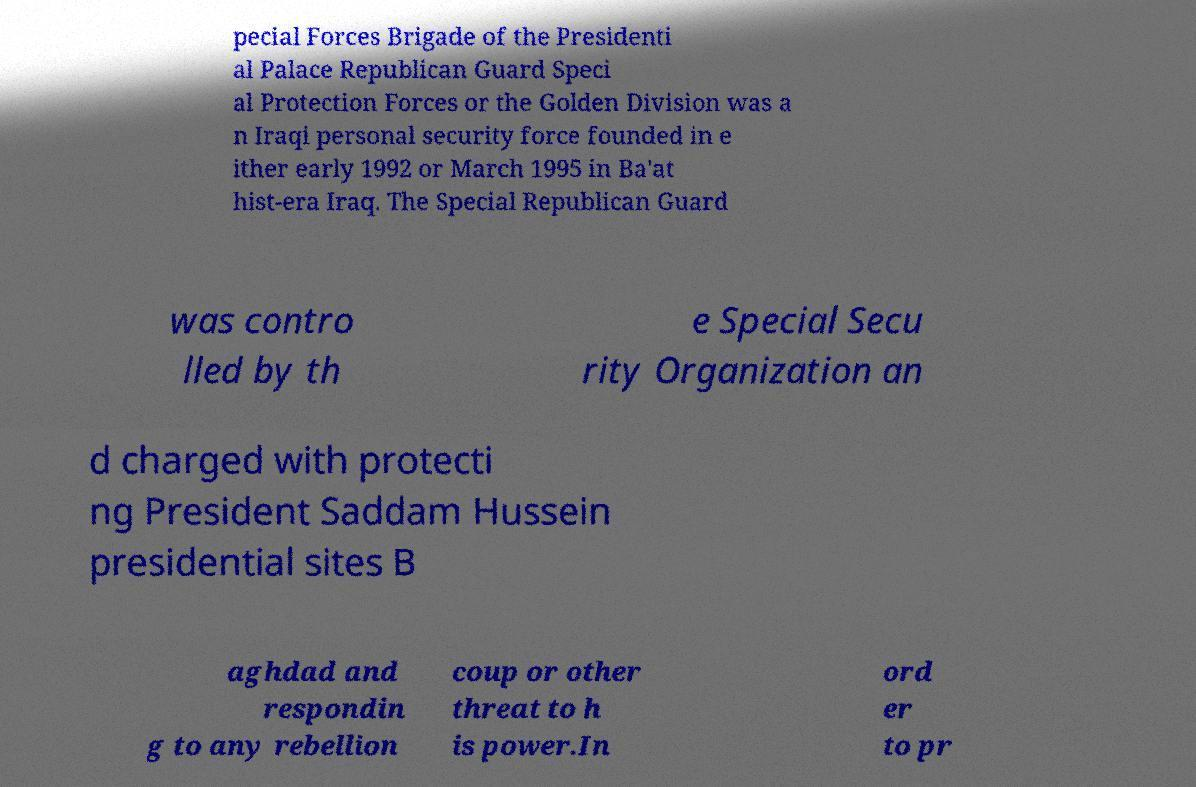Please read and relay the text visible in this image. What does it say? pecial Forces Brigade of the Presidenti al Palace Republican Guard Speci al Protection Forces or the Golden Division was a n Iraqi personal security force founded in e ither early 1992 or March 1995 in Ba'at hist-era Iraq. The Special Republican Guard was contro lled by th e Special Secu rity Organization an d charged with protecti ng President Saddam Hussein presidential sites B aghdad and respondin g to any rebellion coup or other threat to h is power.In ord er to pr 